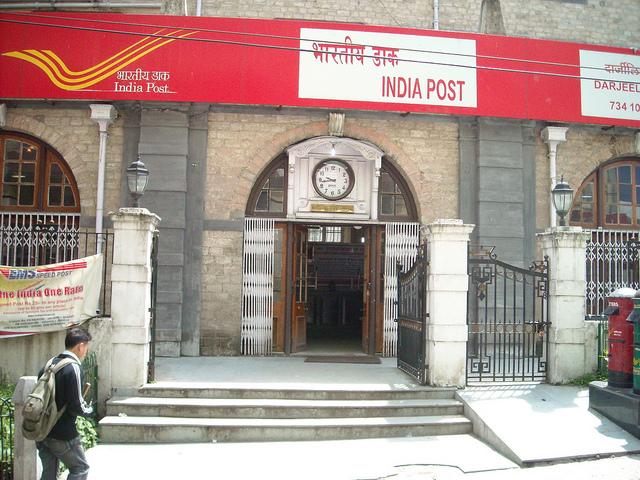What country is this in?
Write a very short answer. India. What time is it?
Quick response, please. 9:45. What is the purpose of the building?
Give a very brief answer. Post office. 